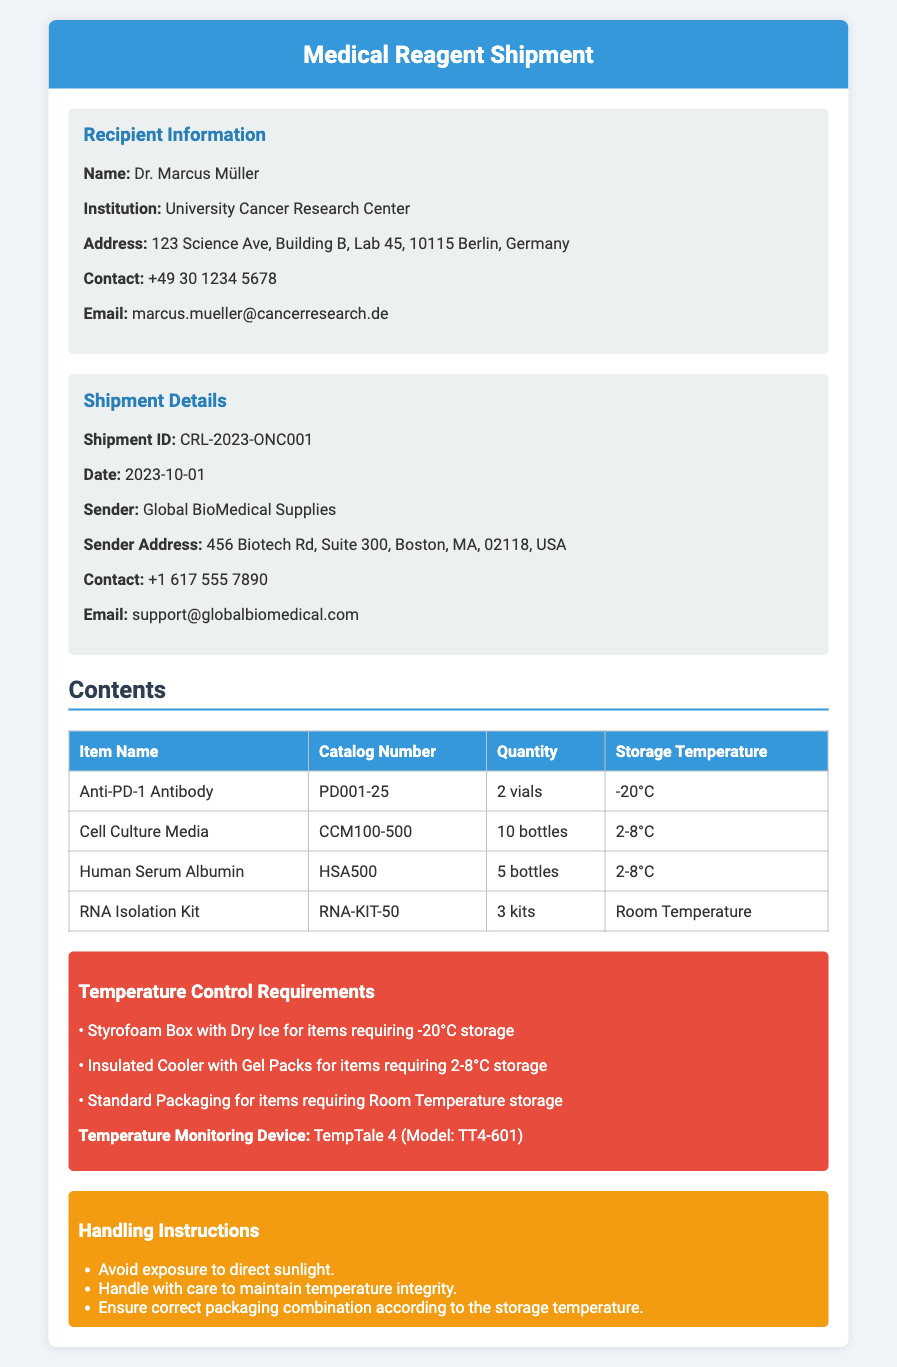Was ist die Sendungs-ID? Die Sendungs-ID ist eine eindeutige Kennung für die Lieferung und steht im Dokument unter den Versanddetails.
Answer: CRL-2023-ONC001 Wie viele Vials von Anti-PD-1 Antikörpern sind enthalten? Die Anzahl der Vials für Anti-PD-1 Antikörper ist in der Tabelle der Inhalte angegeben.
Answer: 2 vials Welche Temperatur sollte für die Lagerung von Zellkulturmedien beibehalten werden? Die Lagerungstemperatur für Zellkulturmedien ist in der Tabelle angegeben.
Answer: 2-8°C Wer ist der Empfänger dieser Lieferung? Der Empfänger ist die Person oder Institution, die die Lieferung erhält, wie im Abschnitt über Empfängerdaten angegeben.
Answer: Dr. Marcus Müller Welche Verpackung ist für Elemente mit einer Lagerungstemperatur von -20°C erforderlich? Die Verpackungsanforderung wird in den Temperaturkontrollanforderungen beschrieben, die im Dokument enthalten sind.
Answer: Styrofoam Box with Dry Ice Was ist das Modell des Temperaturüberwachungsgeräts? Das Modell des Temperaturüberwachungsgeräts wird im Abschnitt über Temperaturkontrollanforderungen erwähnt.
Answer: TT4-601 Nennen Sie einen Teil der Handhabungsanweisungen. Die Handhabungsanweisungen sind wichtige Hinweise, die im entsprechenden Abschnitt aufgeführt sind.
Answer: Avoid exposure to direct sunlight Wann wurde die Sendung verschickt? Das Versanddatum wird in den Versanddetails hervorgehoben.
Answer: 2023-10-01 Wie viele Flaschen von Humanserumalbumin sind enthalten? Die Anzahl der Flaschen von Humanserumalbumin ist in der Inhaltsübersicht angegeben.
Answer: 5 bottles 